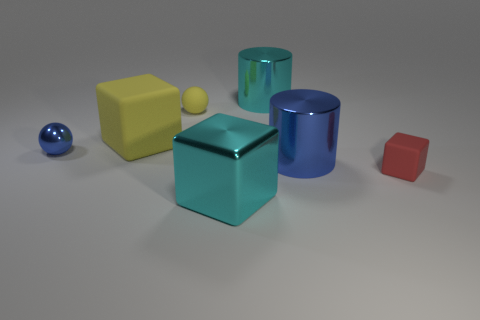Subtract all large yellow cubes. How many cubes are left? 2 Add 1 big metallic cylinders. How many objects exist? 8 Subtract all red blocks. How many blocks are left? 2 Subtract all gray blocks. Subtract all gray spheres. How many blocks are left? 3 Subtract all big gray blocks. Subtract all spheres. How many objects are left? 5 Add 3 red rubber things. How many red rubber things are left? 4 Add 7 red matte things. How many red matte things exist? 8 Subtract 0 purple cylinders. How many objects are left? 7 Subtract all balls. How many objects are left? 5 